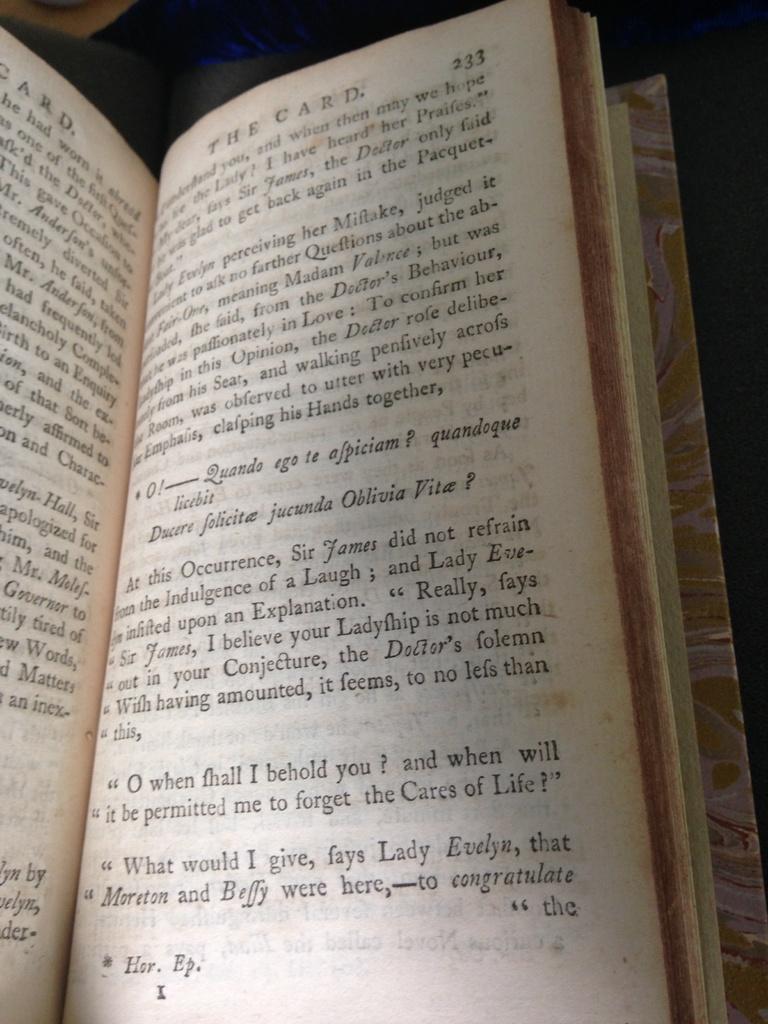What book are they reading?
Offer a very short reply. The card. What is the page number the book is turned to?
Your answer should be compact. 233. 